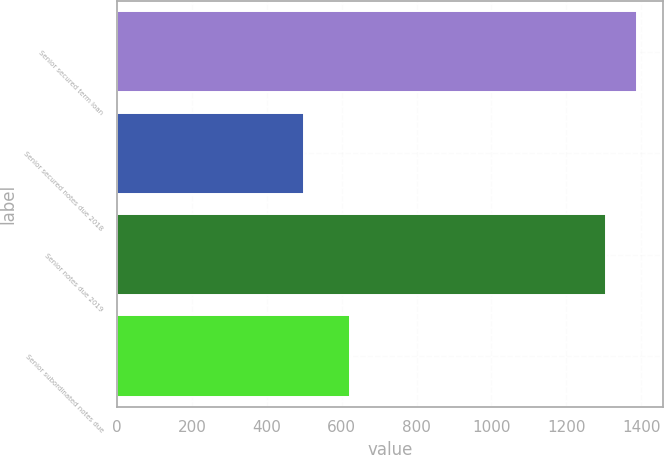Convert chart. <chart><loc_0><loc_0><loc_500><loc_500><bar_chart><fcel>Senior secured term loan<fcel>Senior secured notes due 2018<fcel>Senior notes due 2019<fcel>Senior subordinated notes due<nl><fcel>1388.95<fcel>500<fcel>1305<fcel>621.5<nl></chart> 